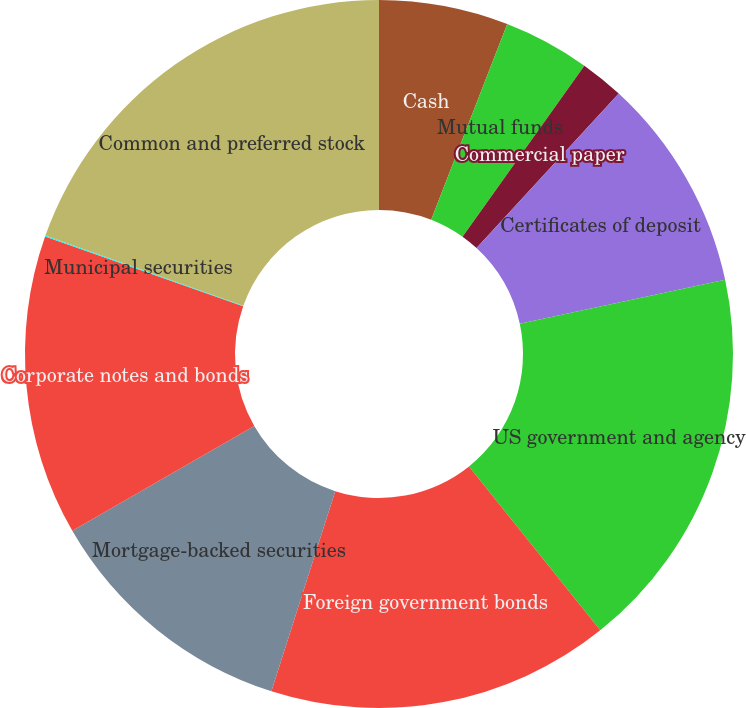Convert chart. <chart><loc_0><loc_0><loc_500><loc_500><pie_chart><fcel>Cash<fcel>Mutual funds<fcel>Commercial paper<fcel>Certificates of deposit<fcel>US government and agency<fcel>Foreign government bonds<fcel>Mortgage-backed securities<fcel>Corporate notes and bonds<fcel>Municipal securities<fcel>Common and preferred stock<nl><fcel>5.9%<fcel>3.95%<fcel>1.99%<fcel>9.8%<fcel>17.61%<fcel>15.66%<fcel>11.76%<fcel>13.71%<fcel>0.04%<fcel>19.57%<nl></chart> 